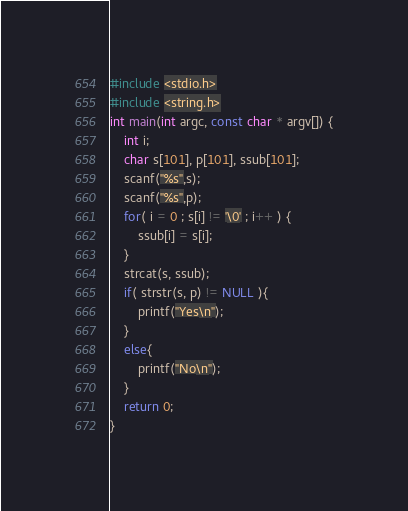<code> <loc_0><loc_0><loc_500><loc_500><_C_>#include <stdio.h>
#include <string.h>
int main(int argc, const char * argv[]) {
    int i;
    char s[101], p[101], ssub[101];
    scanf("%s",s);
    scanf("%s",p);
    for( i = 0 ; s[i] != '\0' ; i++ ) {
        ssub[i] = s[i];
    }
    strcat(s, ssub);
    if( strstr(s, p) != NULL ){
        printf("Yes\n");
    }
    else{
        printf("No\n");
    }
    return 0;
}</code> 